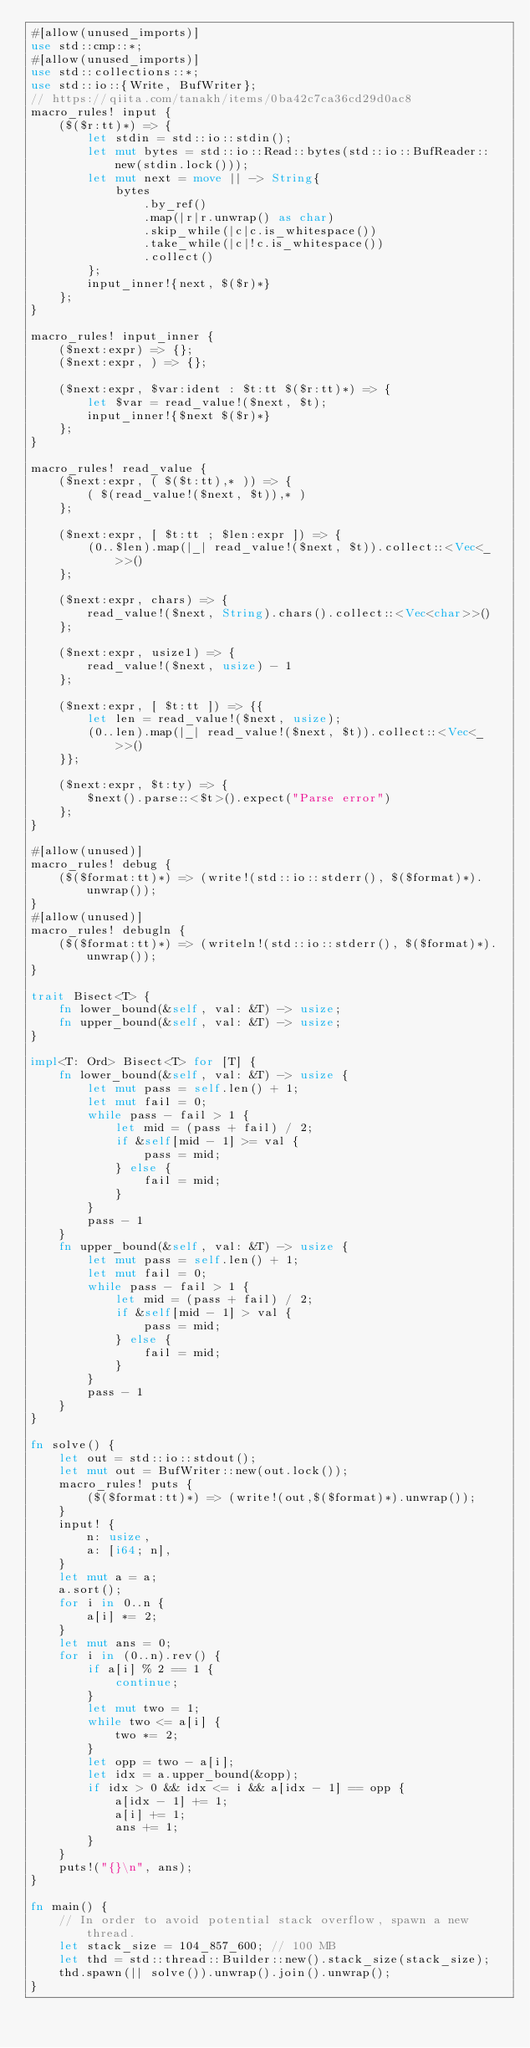Convert code to text. <code><loc_0><loc_0><loc_500><loc_500><_Rust_>#[allow(unused_imports)]
use std::cmp::*;
#[allow(unused_imports)]
use std::collections::*;
use std::io::{Write, BufWriter};
// https://qiita.com/tanakh/items/0ba42c7ca36cd29d0ac8
macro_rules! input {
    ($($r:tt)*) => {
        let stdin = std::io::stdin();
        let mut bytes = std::io::Read::bytes(std::io::BufReader::new(stdin.lock()));
        let mut next = move || -> String{
            bytes
                .by_ref()
                .map(|r|r.unwrap() as char)
                .skip_while(|c|c.is_whitespace())
                .take_while(|c|!c.is_whitespace())
                .collect()
        };
        input_inner!{next, $($r)*}
    };
}

macro_rules! input_inner {
    ($next:expr) => {};
    ($next:expr, ) => {};

    ($next:expr, $var:ident : $t:tt $($r:tt)*) => {
        let $var = read_value!($next, $t);
        input_inner!{$next $($r)*}
    };
}

macro_rules! read_value {
    ($next:expr, ( $($t:tt),* )) => {
        ( $(read_value!($next, $t)),* )
    };

    ($next:expr, [ $t:tt ; $len:expr ]) => {
        (0..$len).map(|_| read_value!($next, $t)).collect::<Vec<_>>()
    };

    ($next:expr, chars) => {
        read_value!($next, String).chars().collect::<Vec<char>>()
    };

    ($next:expr, usize1) => {
        read_value!($next, usize) - 1
    };

    ($next:expr, [ $t:tt ]) => {{
        let len = read_value!($next, usize);
        (0..len).map(|_| read_value!($next, $t)).collect::<Vec<_>>()
    }};

    ($next:expr, $t:ty) => {
        $next().parse::<$t>().expect("Parse error")
    };
}

#[allow(unused)]
macro_rules! debug {
    ($($format:tt)*) => (write!(std::io::stderr(), $($format)*).unwrap());
}
#[allow(unused)]
macro_rules! debugln {
    ($($format:tt)*) => (writeln!(std::io::stderr(), $($format)*).unwrap());
}

trait Bisect<T> {
    fn lower_bound(&self, val: &T) -> usize;
    fn upper_bound(&self, val: &T) -> usize;
}

impl<T: Ord> Bisect<T> for [T] {
    fn lower_bound(&self, val: &T) -> usize {
        let mut pass = self.len() + 1;
        let mut fail = 0;
        while pass - fail > 1 {
            let mid = (pass + fail) / 2;
            if &self[mid - 1] >= val {
                pass = mid;
            } else {
                fail = mid;
            }
        }
        pass - 1
    }
    fn upper_bound(&self, val: &T) -> usize {
        let mut pass = self.len() + 1;
        let mut fail = 0;
        while pass - fail > 1 {
            let mid = (pass + fail) / 2;
            if &self[mid - 1] > val {
                pass = mid;
            } else {
                fail = mid;
            }
        }
        pass - 1
    }
}

fn solve() {
    let out = std::io::stdout();
    let mut out = BufWriter::new(out.lock());
    macro_rules! puts {
        ($($format:tt)*) => (write!(out,$($format)*).unwrap());
    }
    input! {
        n: usize,
        a: [i64; n],
    }
    let mut a = a;
    a.sort();
    for i in 0..n {
        a[i] *= 2;
    }
    let mut ans = 0;
    for i in (0..n).rev() {
        if a[i] % 2 == 1 {
            continue;
        }
        let mut two = 1;
        while two <= a[i] {
            two *= 2;
        }
        let opp = two - a[i];
        let idx = a.upper_bound(&opp);
        if idx > 0 && idx <= i && a[idx - 1] == opp {
            a[idx - 1] += 1;
            a[i] += 1;
            ans += 1;
        }
    }
    puts!("{}\n", ans);
}

fn main() {
    // In order to avoid potential stack overflow, spawn a new thread.
    let stack_size = 104_857_600; // 100 MB
    let thd = std::thread::Builder::new().stack_size(stack_size);
    thd.spawn(|| solve()).unwrap().join().unwrap();
}
</code> 